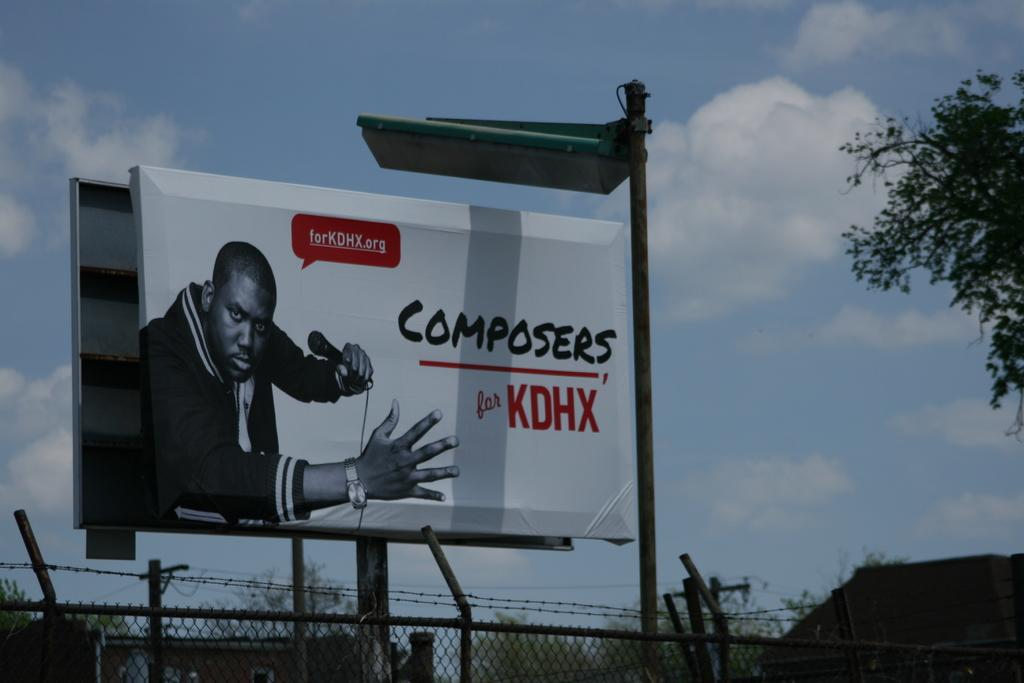<image>
Present a compact description of the photo's key features. A billboard advertises composers for KDHX and shows a photo of a man with a microphone. 